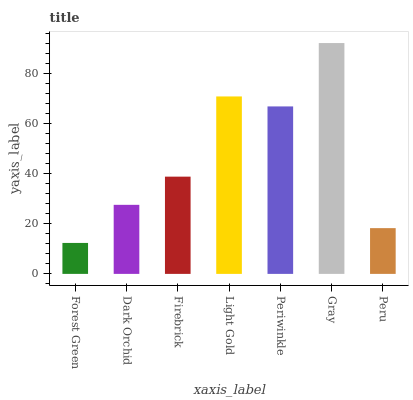Is Dark Orchid the minimum?
Answer yes or no. No. Is Dark Orchid the maximum?
Answer yes or no. No. Is Dark Orchid greater than Forest Green?
Answer yes or no. Yes. Is Forest Green less than Dark Orchid?
Answer yes or no. Yes. Is Forest Green greater than Dark Orchid?
Answer yes or no. No. Is Dark Orchid less than Forest Green?
Answer yes or no. No. Is Firebrick the high median?
Answer yes or no. Yes. Is Firebrick the low median?
Answer yes or no. Yes. Is Peru the high median?
Answer yes or no. No. Is Gray the low median?
Answer yes or no. No. 